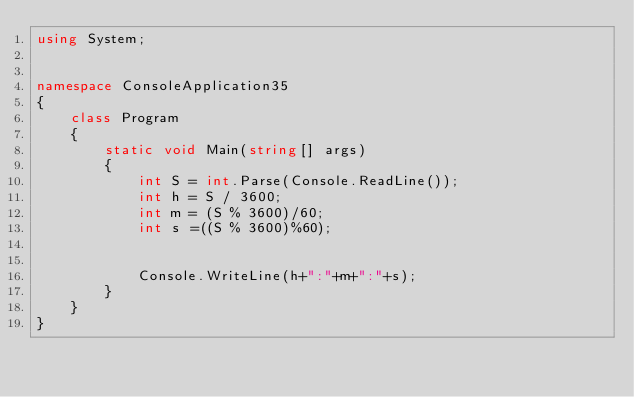<code> <loc_0><loc_0><loc_500><loc_500><_C#_>using System;


namespace ConsoleApplication35
{
    class Program
    {
        static void Main(string[] args)
        {
            int S = int.Parse(Console.ReadLine());
            int h = S / 3600;
            int m = (S % 3600)/60;
            int s =((S % 3600)%60);


            Console.WriteLine(h+":"+m+":"+s);
        }
    }
}</code> 